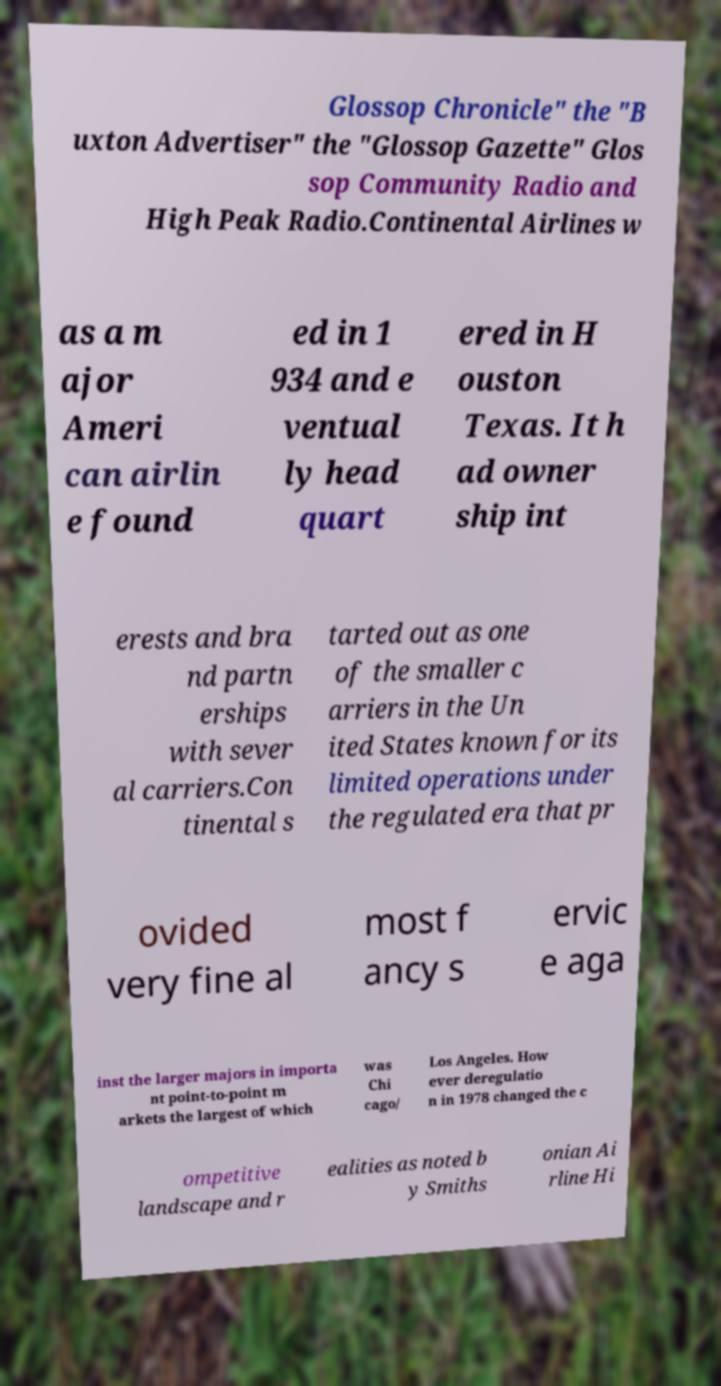Can you read and provide the text displayed in the image?This photo seems to have some interesting text. Can you extract and type it out for me? Glossop Chronicle" the "B uxton Advertiser" the "Glossop Gazette" Glos sop Community Radio and High Peak Radio.Continental Airlines w as a m ajor Ameri can airlin e found ed in 1 934 and e ventual ly head quart ered in H ouston Texas. It h ad owner ship int erests and bra nd partn erships with sever al carriers.Con tinental s tarted out as one of the smaller c arriers in the Un ited States known for its limited operations under the regulated era that pr ovided very fine al most f ancy s ervic e aga inst the larger majors in importa nt point-to-point m arkets the largest of which was Chi cago/ Los Angeles. How ever deregulatio n in 1978 changed the c ompetitive landscape and r ealities as noted b y Smiths onian Ai rline Hi 